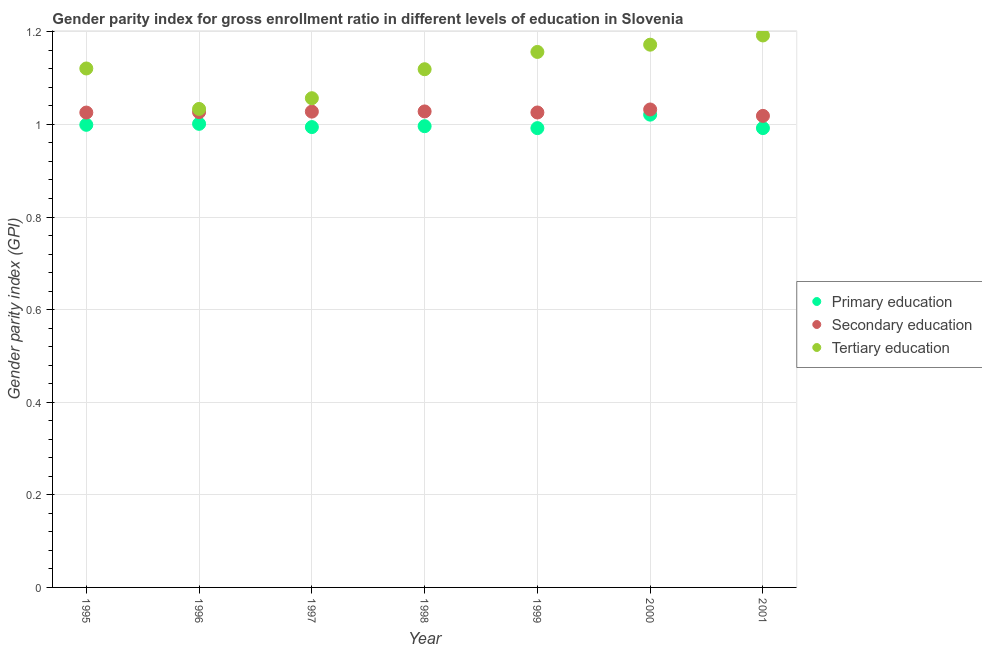What is the gender parity index in secondary education in 1996?
Provide a succinct answer. 1.03. Across all years, what is the maximum gender parity index in secondary education?
Your response must be concise. 1.03. Across all years, what is the minimum gender parity index in primary education?
Your answer should be very brief. 0.99. In which year was the gender parity index in secondary education maximum?
Provide a short and direct response. 2000. In which year was the gender parity index in tertiary education minimum?
Your answer should be compact. 1996. What is the total gender parity index in secondary education in the graph?
Offer a terse response. 7.18. What is the difference between the gender parity index in tertiary education in 1995 and that in 1998?
Your response must be concise. 0. What is the difference between the gender parity index in secondary education in 2001 and the gender parity index in primary education in 1999?
Ensure brevity in your answer.  0.03. What is the average gender parity index in secondary education per year?
Keep it short and to the point. 1.03. In the year 1997, what is the difference between the gender parity index in tertiary education and gender parity index in secondary education?
Give a very brief answer. 0.03. In how many years, is the gender parity index in primary education greater than 1.04?
Offer a very short reply. 0. What is the ratio of the gender parity index in secondary education in 1997 to that in 1998?
Keep it short and to the point. 1. Is the gender parity index in secondary education in 1995 less than that in 1998?
Your response must be concise. Yes. What is the difference between the highest and the second highest gender parity index in secondary education?
Offer a terse response. 0. What is the difference between the highest and the lowest gender parity index in primary education?
Offer a terse response. 0.03. Is the sum of the gender parity index in primary education in 1997 and 2001 greater than the maximum gender parity index in tertiary education across all years?
Keep it short and to the point. Yes. Does the gender parity index in secondary education monotonically increase over the years?
Provide a succinct answer. No. Is the gender parity index in tertiary education strictly less than the gender parity index in primary education over the years?
Offer a terse response. No. How many dotlines are there?
Offer a very short reply. 3. How many years are there in the graph?
Offer a terse response. 7. What is the difference between two consecutive major ticks on the Y-axis?
Give a very brief answer. 0.2. Does the graph contain any zero values?
Ensure brevity in your answer.  No. Does the graph contain grids?
Ensure brevity in your answer.  Yes. How many legend labels are there?
Offer a very short reply. 3. What is the title of the graph?
Provide a succinct answer. Gender parity index for gross enrollment ratio in different levels of education in Slovenia. Does "Poland" appear as one of the legend labels in the graph?
Provide a short and direct response. No. What is the label or title of the Y-axis?
Give a very brief answer. Gender parity index (GPI). What is the Gender parity index (GPI) in Primary education in 1995?
Offer a very short reply. 1. What is the Gender parity index (GPI) of Secondary education in 1995?
Offer a terse response. 1.03. What is the Gender parity index (GPI) in Tertiary education in 1995?
Give a very brief answer. 1.12. What is the Gender parity index (GPI) in Primary education in 1996?
Ensure brevity in your answer.  1. What is the Gender parity index (GPI) of Secondary education in 1996?
Offer a terse response. 1.03. What is the Gender parity index (GPI) in Tertiary education in 1996?
Give a very brief answer. 1.03. What is the Gender parity index (GPI) in Primary education in 1997?
Keep it short and to the point. 0.99. What is the Gender parity index (GPI) of Secondary education in 1997?
Your response must be concise. 1.03. What is the Gender parity index (GPI) of Tertiary education in 1997?
Your answer should be compact. 1.06. What is the Gender parity index (GPI) of Primary education in 1998?
Make the answer very short. 1. What is the Gender parity index (GPI) in Secondary education in 1998?
Your response must be concise. 1.03. What is the Gender parity index (GPI) in Tertiary education in 1998?
Your response must be concise. 1.12. What is the Gender parity index (GPI) of Primary education in 1999?
Provide a succinct answer. 0.99. What is the Gender parity index (GPI) in Secondary education in 1999?
Provide a succinct answer. 1.03. What is the Gender parity index (GPI) in Tertiary education in 1999?
Offer a very short reply. 1.16. What is the Gender parity index (GPI) in Primary education in 2000?
Ensure brevity in your answer.  1.02. What is the Gender parity index (GPI) of Secondary education in 2000?
Give a very brief answer. 1.03. What is the Gender parity index (GPI) of Tertiary education in 2000?
Your answer should be very brief. 1.17. What is the Gender parity index (GPI) in Primary education in 2001?
Make the answer very short. 0.99. What is the Gender parity index (GPI) in Secondary education in 2001?
Offer a very short reply. 1.02. What is the Gender parity index (GPI) of Tertiary education in 2001?
Offer a very short reply. 1.19. Across all years, what is the maximum Gender parity index (GPI) of Primary education?
Your response must be concise. 1.02. Across all years, what is the maximum Gender parity index (GPI) in Secondary education?
Provide a succinct answer. 1.03. Across all years, what is the maximum Gender parity index (GPI) in Tertiary education?
Your answer should be very brief. 1.19. Across all years, what is the minimum Gender parity index (GPI) of Primary education?
Offer a very short reply. 0.99. Across all years, what is the minimum Gender parity index (GPI) of Secondary education?
Keep it short and to the point. 1.02. Across all years, what is the minimum Gender parity index (GPI) in Tertiary education?
Provide a succinct answer. 1.03. What is the total Gender parity index (GPI) in Primary education in the graph?
Give a very brief answer. 7. What is the total Gender parity index (GPI) of Secondary education in the graph?
Your answer should be very brief. 7.18. What is the total Gender parity index (GPI) in Tertiary education in the graph?
Your answer should be compact. 7.85. What is the difference between the Gender parity index (GPI) in Primary education in 1995 and that in 1996?
Offer a very short reply. -0. What is the difference between the Gender parity index (GPI) in Secondary education in 1995 and that in 1996?
Provide a succinct answer. -0. What is the difference between the Gender parity index (GPI) in Tertiary education in 1995 and that in 1996?
Keep it short and to the point. 0.09. What is the difference between the Gender parity index (GPI) in Primary education in 1995 and that in 1997?
Your answer should be very brief. 0. What is the difference between the Gender parity index (GPI) in Secondary education in 1995 and that in 1997?
Offer a very short reply. -0. What is the difference between the Gender parity index (GPI) of Tertiary education in 1995 and that in 1997?
Your response must be concise. 0.06. What is the difference between the Gender parity index (GPI) of Primary education in 1995 and that in 1998?
Your response must be concise. 0. What is the difference between the Gender parity index (GPI) of Secondary education in 1995 and that in 1998?
Provide a succinct answer. -0. What is the difference between the Gender parity index (GPI) of Tertiary education in 1995 and that in 1998?
Make the answer very short. 0. What is the difference between the Gender parity index (GPI) in Primary education in 1995 and that in 1999?
Your answer should be compact. 0.01. What is the difference between the Gender parity index (GPI) of Secondary education in 1995 and that in 1999?
Give a very brief answer. -0. What is the difference between the Gender parity index (GPI) of Tertiary education in 1995 and that in 1999?
Your answer should be very brief. -0.04. What is the difference between the Gender parity index (GPI) of Primary education in 1995 and that in 2000?
Your answer should be very brief. -0.02. What is the difference between the Gender parity index (GPI) of Secondary education in 1995 and that in 2000?
Give a very brief answer. -0.01. What is the difference between the Gender parity index (GPI) of Tertiary education in 1995 and that in 2000?
Your response must be concise. -0.05. What is the difference between the Gender parity index (GPI) of Primary education in 1995 and that in 2001?
Provide a short and direct response. 0.01. What is the difference between the Gender parity index (GPI) in Secondary education in 1995 and that in 2001?
Keep it short and to the point. 0.01. What is the difference between the Gender parity index (GPI) in Tertiary education in 1995 and that in 2001?
Provide a succinct answer. -0.07. What is the difference between the Gender parity index (GPI) of Primary education in 1996 and that in 1997?
Provide a short and direct response. 0.01. What is the difference between the Gender parity index (GPI) of Secondary education in 1996 and that in 1997?
Keep it short and to the point. -0. What is the difference between the Gender parity index (GPI) of Tertiary education in 1996 and that in 1997?
Provide a short and direct response. -0.02. What is the difference between the Gender parity index (GPI) in Primary education in 1996 and that in 1998?
Provide a short and direct response. 0.01. What is the difference between the Gender parity index (GPI) in Secondary education in 1996 and that in 1998?
Provide a short and direct response. -0. What is the difference between the Gender parity index (GPI) in Tertiary education in 1996 and that in 1998?
Offer a terse response. -0.09. What is the difference between the Gender parity index (GPI) in Primary education in 1996 and that in 1999?
Your answer should be very brief. 0.01. What is the difference between the Gender parity index (GPI) of Secondary education in 1996 and that in 1999?
Offer a terse response. 0. What is the difference between the Gender parity index (GPI) in Tertiary education in 1996 and that in 1999?
Your response must be concise. -0.12. What is the difference between the Gender parity index (GPI) in Primary education in 1996 and that in 2000?
Provide a short and direct response. -0.02. What is the difference between the Gender parity index (GPI) in Secondary education in 1996 and that in 2000?
Give a very brief answer. -0.01. What is the difference between the Gender parity index (GPI) in Tertiary education in 1996 and that in 2000?
Ensure brevity in your answer.  -0.14. What is the difference between the Gender parity index (GPI) of Primary education in 1996 and that in 2001?
Your answer should be compact. 0.01. What is the difference between the Gender parity index (GPI) of Secondary education in 1996 and that in 2001?
Keep it short and to the point. 0.01. What is the difference between the Gender parity index (GPI) in Tertiary education in 1996 and that in 2001?
Offer a very short reply. -0.16. What is the difference between the Gender parity index (GPI) of Primary education in 1997 and that in 1998?
Ensure brevity in your answer.  -0. What is the difference between the Gender parity index (GPI) in Secondary education in 1997 and that in 1998?
Offer a terse response. -0. What is the difference between the Gender parity index (GPI) of Tertiary education in 1997 and that in 1998?
Your answer should be very brief. -0.06. What is the difference between the Gender parity index (GPI) in Primary education in 1997 and that in 1999?
Ensure brevity in your answer.  0. What is the difference between the Gender parity index (GPI) of Secondary education in 1997 and that in 1999?
Provide a short and direct response. 0. What is the difference between the Gender parity index (GPI) of Tertiary education in 1997 and that in 1999?
Your answer should be compact. -0.1. What is the difference between the Gender parity index (GPI) in Primary education in 1997 and that in 2000?
Give a very brief answer. -0.03. What is the difference between the Gender parity index (GPI) in Secondary education in 1997 and that in 2000?
Provide a short and direct response. -0. What is the difference between the Gender parity index (GPI) of Tertiary education in 1997 and that in 2000?
Your response must be concise. -0.12. What is the difference between the Gender parity index (GPI) in Primary education in 1997 and that in 2001?
Provide a succinct answer. 0. What is the difference between the Gender parity index (GPI) of Secondary education in 1997 and that in 2001?
Keep it short and to the point. 0.01. What is the difference between the Gender parity index (GPI) of Tertiary education in 1997 and that in 2001?
Your answer should be compact. -0.14. What is the difference between the Gender parity index (GPI) in Primary education in 1998 and that in 1999?
Ensure brevity in your answer.  0. What is the difference between the Gender parity index (GPI) of Secondary education in 1998 and that in 1999?
Your answer should be very brief. 0. What is the difference between the Gender parity index (GPI) of Tertiary education in 1998 and that in 1999?
Your response must be concise. -0.04. What is the difference between the Gender parity index (GPI) in Primary education in 1998 and that in 2000?
Offer a very short reply. -0.02. What is the difference between the Gender parity index (GPI) of Secondary education in 1998 and that in 2000?
Ensure brevity in your answer.  -0. What is the difference between the Gender parity index (GPI) in Tertiary education in 1998 and that in 2000?
Your answer should be very brief. -0.05. What is the difference between the Gender parity index (GPI) in Primary education in 1998 and that in 2001?
Your answer should be very brief. 0. What is the difference between the Gender parity index (GPI) in Secondary education in 1998 and that in 2001?
Offer a terse response. 0.01. What is the difference between the Gender parity index (GPI) in Tertiary education in 1998 and that in 2001?
Your answer should be very brief. -0.07. What is the difference between the Gender parity index (GPI) in Primary education in 1999 and that in 2000?
Your answer should be compact. -0.03. What is the difference between the Gender parity index (GPI) of Secondary education in 1999 and that in 2000?
Your answer should be very brief. -0.01. What is the difference between the Gender parity index (GPI) in Tertiary education in 1999 and that in 2000?
Provide a short and direct response. -0.02. What is the difference between the Gender parity index (GPI) of Primary education in 1999 and that in 2001?
Provide a succinct answer. -0. What is the difference between the Gender parity index (GPI) in Secondary education in 1999 and that in 2001?
Provide a succinct answer. 0.01. What is the difference between the Gender parity index (GPI) in Tertiary education in 1999 and that in 2001?
Your answer should be very brief. -0.04. What is the difference between the Gender parity index (GPI) of Primary education in 2000 and that in 2001?
Your response must be concise. 0.03. What is the difference between the Gender parity index (GPI) in Secondary education in 2000 and that in 2001?
Give a very brief answer. 0.01. What is the difference between the Gender parity index (GPI) of Tertiary education in 2000 and that in 2001?
Your answer should be very brief. -0.02. What is the difference between the Gender parity index (GPI) in Primary education in 1995 and the Gender parity index (GPI) in Secondary education in 1996?
Give a very brief answer. -0.03. What is the difference between the Gender parity index (GPI) of Primary education in 1995 and the Gender parity index (GPI) of Tertiary education in 1996?
Your answer should be very brief. -0.03. What is the difference between the Gender parity index (GPI) of Secondary education in 1995 and the Gender parity index (GPI) of Tertiary education in 1996?
Your response must be concise. -0.01. What is the difference between the Gender parity index (GPI) of Primary education in 1995 and the Gender parity index (GPI) of Secondary education in 1997?
Offer a terse response. -0.03. What is the difference between the Gender parity index (GPI) in Primary education in 1995 and the Gender parity index (GPI) in Tertiary education in 1997?
Give a very brief answer. -0.06. What is the difference between the Gender parity index (GPI) in Secondary education in 1995 and the Gender parity index (GPI) in Tertiary education in 1997?
Give a very brief answer. -0.03. What is the difference between the Gender parity index (GPI) of Primary education in 1995 and the Gender parity index (GPI) of Secondary education in 1998?
Provide a short and direct response. -0.03. What is the difference between the Gender parity index (GPI) in Primary education in 1995 and the Gender parity index (GPI) in Tertiary education in 1998?
Offer a terse response. -0.12. What is the difference between the Gender parity index (GPI) in Secondary education in 1995 and the Gender parity index (GPI) in Tertiary education in 1998?
Provide a succinct answer. -0.09. What is the difference between the Gender parity index (GPI) of Primary education in 1995 and the Gender parity index (GPI) of Secondary education in 1999?
Keep it short and to the point. -0.03. What is the difference between the Gender parity index (GPI) in Primary education in 1995 and the Gender parity index (GPI) in Tertiary education in 1999?
Provide a succinct answer. -0.16. What is the difference between the Gender parity index (GPI) in Secondary education in 1995 and the Gender parity index (GPI) in Tertiary education in 1999?
Provide a succinct answer. -0.13. What is the difference between the Gender parity index (GPI) in Primary education in 1995 and the Gender parity index (GPI) in Secondary education in 2000?
Offer a terse response. -0.03. What is the difference between the Gender parity index (GPI) of Primary education in 1995 and the Gender parity index (GPI) of Tertiary education in 2000?
Give a very brief answer. -0.17. What is the difference between the Gender parity index (GPI) in Secondary education in 1995 and the Gender parity index (GPI) in Tertiary education in 2000?
Offer a very short reply. -0.15. What is the difference between the Gender parity index (GPI) in Primary education in 1995 and the Gender parity index (GPI) in Secondary education in 2001?
Offer a very short reply. -0.02. What is the difference between the Gender parity index (GPI) of Primary education in 1995 and the Gender parity index (GPI) of Tertiary education in 2001?
Offer a terse response. -0.19. What is the difference between the Gender parity index (GPI) in Secondary education in 1995 and the Gender parity index (GPI) in Tertiary education in 2001?
Your response must be concise. -0.17. What is the difference between the Gender parity index (GPI) in Primary education in 1996 and the Gender parity index (GPI) in Secondary education in 1997?
Your answer should be compact. -0.03. What is the difference between the Gender parity index (GPI) in Primary education in 1996 and the Gender parity index (GPI) in Tertiary education in 1997?
Keep it short and to the point. -0.06. What is the difference between the Gender parity index (GPI) in Secondary education in 1996 and the Gender parity index (GPI) in Tertiary education in 1997?
Your answer should be very brief. -0.03. What is the difference between the Gender parity index (GPI) in Primary education in 1996 and the Gender parity index (GPI) in Secondary education in 1998?
Keep it short and to the point. -0.03. What is the difference between the Gender parity index (GPI) of Primary education in 1996 and the Gender parity index (GPI) of Tertiary education in 1998?
Keep it short and to the point. -0.12. What is the difference between the Gender parity index (GPI) of Secondary education in 1996 and the Gender parity index (GPI) of Tertiary education in 1998?
Offer a terse response. -0.09. What is the difference between the Gender parity index (GPI) in Primary education in 1996 and the Gender parity index (GPI) in Secondary education in 1999?
Your answer should be very brief. -0.02. What is the difference between the Gender parity index (GPI) of Primary education in 1996 and the Gender parity index (GPI) of Tertiary education in 1999?
Your response must be concise. -0.16. What is the difference between the Gender parity index (GPI) in Secondary education in 1996 and the Gender parity index (GPI) in Tertiary education in 1999?
Keep it short and to the point. -0.13. What is the difference between the Gender parity index (GPI) of Primary education in 1996 and the Gender parity index (GPI) of Secondary education in 2000?
Your response must be concise. -0.03. What is the difference between the Gender parity index (GPI) of Primary education in 1996 and the Gender parity index (GPI) of Tertiary education in 2000?
Your answer should be very brief. -0.17. What is the difference between the Gender parity index (GPI) of Secondary education in 1996 and the Gender parity index (GPI) of Tertiary education in 2000?
Give a very brief answer. -0.15. What is the difference between the Gender parity index (GPI) of Primary education in 1996 and the Gender parity index (GPI) of Secondary education in 2001?
Make the answer very short. -0.02. What is the difference between the Gender parity index (GPI) of Primary education in 1996 and the Gender parity index (GPI) of Tertiary education in 2001?
Your answer should be very brief. -0.19. What is the difference between the Gender parity index (GPI) of Secondary education in 1996 and the Gender parity index (GPI) of Tertiary education in 2001?
Keep it short and to the point. -0.17. What is the difference between the Gender parity index (GPI) of Primary education in 1997 and the Gender parity index (GPI) of Secondary education in 1998?
Your answer should be very brief. -0.03. What is the difference between the Gender parity index (GPI) in Primary education in 1997 and the Gender parity index (GPI) in Tertiary education in 1998?
Your answer should be compact. -0.12. What is the difference between the Gender parity index (GPI) in Secondary education in 1997 and the Gender parity index (GPI) in Tertiary education in 1998?
Your answer should be very brief. -0.09. What is the difference between the Gender parity index (GPI) in Primary education in 1997 and the Gender parity index (GPI) in Secondary education in 1999?
Your answer should be compact. -0.03. What is the difference between the Gender parity index (GPI) in Primary education in 1997 and the Gender parity index (GPI) in Tertiary education in 1999?
Offer a terse response. -0.16. What is the difference between the Gender parity index (GPI) of Secondary education in 1997 and the Gender parity index (GPI) of Tertiary education in 1999?
Ensure brevity in your answer.  -0.13. What is the difference between the Gender parity index (GPI) of Primary education in 1997 and the Gender parity index (GPI) of Secondary education in 2000?
Offer a very short reply. -0.04. What is the difference between the Gender parity index (GPI) in Primary education in 1997 and the Gender parity index (GPI) in Tertiary education in 2000?
Offer a terse response. -0.18. What is the difference between the Gender parity index (GPI) of Secondary education in 1997 and the Gender parity index (GPI) of Tertiary education in 2000?
Your answer should be compact. -0.14. What is the difference between the Gender parity index (GPI) in Primary education in 1997 and the Gender parity index (GPI) in Secondary education in 2001?
Your answer should be compact. -0.02. What is the difference between the Gender parity index (GPI) of Primary education in 1997 and the Gender parity index (GPI) of Tertiary education in 2001?
Keep it short and to the point. -0.2. What is the difference between the Gender parity index (GPI) in Secondary education in 1997 and the Gender parity index (GPI) in Tertiary education in 2001?
Offer a very short reply. -0.16. What is the difference between the Gender parity index (GPI) of Primary education in 1998 and the Gender parity index (GPI) of Secondary education in 1999?
Your response must be concise. -0.03. What is the difference between the Gender parity index (GPI) of Primary education in 1998 and the Gender parity index (GPI) of Tertiary education in 1999?
Keep it short and to the point. -0.16. What is the difference between the Gender parity index (GPI) in Secondary education in 1998 and the Gender parity index (GPI) in Tertiary education in 1999?
Ensure brevity in your answer.  -0.13. What is the difference between the Gender parity index (GPI) of Primary education in 1998 and the Gender parity index (GPI) of Secondary education in 2000?
Give a very brief answer. -0.04. What is the difference between the Gender parity index (GPI) in Primary education in 1998 and the Gender parity index (GPI) in Tertiary education in 2000?
Ensure brevity in your answer.  -0.18. What is the difference between the Gender parity index (GPI) of Secondary education in 1998 and the Gender parity index (GPI) of Tertiary education in 2000?
Your answer should be very brief. -0.14. What is the difference between the Gender parity index (GPI) of Primary education in 1998 and the Gender parity index (GPI) of Secondary education in 2001?
Your answer should be compact. -0.02. What is the difference between the Gender parity index (GPI) in Primary education in 1998 and the Gender parity index (GPI) in Tertiary education in 2001?
Give a very brief answer. -0.2. What is the difference between the Gender parity index (GPI) of Secondary education in 1998 and the Gender parity index (GPI) of Tertiary education in 2001?
Offer a very short reply. -0.16. What is the difference between the Gender parity index (GPI) of Primary education in 1999 and the Gender parity index (GPI) of Secondary education in 2000?
Offer a very short reply. -0.04. What is the difference between the Gender parity index (GPI) of Primary education in 1999 and the Gender parity index (GPI) of Tertiary education in 2000?
Offer a very short reply. -0.18. What is the difference between the Gender parity index (GPI) in Secondary education in 1999 and the Gender parity index (GPI) in Tertiary education in 2000?
Your answer should be compact. -0.15. What is the difference between the Gender parity index (GPI) of Primary education in 1999 and the Gender parity index (GPI) of Secondary education in 2001?
Offer a terse response. -0.03. What is the difference between the Gender parity index (GPI) of Primary education in 1999 and the Gender parity index (GPI) of Tertiary education in 2001?
Offer a terse response. -0.2. What is the difference between the Gender parity index (GPI) in Secondary education in 1999 and the Gender parity index (GPI) in Tertiary education in 2001?
Your answer should be compact. -0.17. What is the difference between the Gender parity index (GPI) in Primary education in 2000 and the Gender parity index (GPI) in Secondary education in 2001?
Your response must be concise. 0. What is the difference between the Gender parity index (GPI) of Primary education in 2000 and the Gender parity index (GPI) of Tertiary education in 2001?
Your answer should be very brief. -0.17. What is the difference between the Gender parity index (GPI) of Secondary education in 2000 and the Gender parity index (GPI) of Tertiary education in 2001?
Provide a succinct answer. -0.16. What is the average Gender parity index (GPI) in Primary education per year?
Make the answer very short. 1. What is the average Gender parity index (GPI) in Secondary education per year?
Your response must be concise. 1.03. What is the average Gender parity index (GPI) in Tertiary education per year?
Your answer should be very brief. 1.12. In the year 1995, what is the difference between the Gender parity index (GPI) in Primary education and Gender parity index (GPI) in Secondary education?
Offer a very short reply. -0.03. In the year 1995, what is the difference between the Gender parity index (GPI) of Primary education and Gender parity index (GPI) of Tertiary education?
Keep it short and to the point. -0.12. In the year 1995, what is the difference between the Gender parity index (GPI) in Secondary education and Gender parity index (GPI) in Tertiary education?
Ensure brevity in your answer.  -0.1. In the year 1996, what is the difference between the Gender parity index (GPI) of Primary education and Gender parity index (GPI) of Secondary education?
Offer a very short reply. -0.03. In the year 1996, what is the difference between the Gender parity index (GPI) in Primary education and Gender parity index (GPI) in Tertiary education?
Your response must be concise. -0.03. In the year 1996, what is the difference between the Gender parity index (GPI) in Secondary education and Gender parity index (GPI) in Tertiary education?
Ensure brevity in your answer.  -0.01. In the year 1997, what is the difference between the Gender parity index (GPI) of Primary education and Gender parity index (GPI) of Secondary education?
Offer a very short reply. -0.03. In the year 1997, what is the difference between the Gender parity index (GPI) in Primary education and Gender parity index (GPI) in Tertiary education?
Provide a succinct answer. -0.06. In the year 1997, what is the difference between the Gender parity index (GPI) of Secondary education and Gender parity index (GPI) of Tertiary education?
Provide a succinct answer. -0.03. In the year 1998, what is the difference between the Gender parity index (GPI) of Primary education and Gender parity index (GPI) of Secondary education?
Make the answer very short. -0.03. In the year 1998, what is the difference between the Gender parity index (GPI) in Primary education and Gender parity index (GPI) in Tertiary education?
Offer a very short reply. -0.12. In the year 1998, what is the difference between the Gender parity index (GPI) of Secondary education and Gender parity index (GPI) of Tertiary education?
Offer a terse response. -0.09. In the year 1999, what is the difference between the Gender parity index (GPI) in Primary education and Gender parity index (GPI) in Secondary education?
Make the answer very short. -0.03. In the year 1999, what is the difference between the Gender parity index (GPI) in Primary education and Gender parity index (GPI) in Tertiary education?
Make the answer very short. -0.16. In the year 1999, what is the difference between the Gender parity index (GPI) of Secondary education and Gender parity index (GPI) of Tertiary education?
Provide a succinct answer. -0.13. In the year 2000, what is the difference between the Gender parity index (GPI) in Primary education and Gender parity index (GPI) in Secondary education?
Keep it short and to the point. -0.01. In the year 2000, what is the difference between the Gender parity index (GPI) in Primary education and Gender parity index (GPI) in Tertiary education?
Make the answer very short. -0.15. In the year 2000, what is the difference between the Gender parity index (GPI) of Secondary education and Gender parity index (GPI) of Tertiary education?
Your response must be concise. -0.14. In the year 2001, what is the difference between the Gender parity index (GPI) in Primary education and Gender parity index (GPI) in Secondary education?
Ensure brevity in your answer.  -0.03. In the year 2001, what is the difference between the Gender parity index (GPI) of Primary education and Gender parity index (GPI) of Tertiary education?
Offer a terse response. -0.2. In the year 2001, what is the difference between the Gender parity index (GPI) of Secondary education and Gender parity index (GPI) of Tertiary education?
Offer a very short reply. -0.17. What is the ratio of the Gender parity index (GPI) in Primary education in 1995 to that in 1996?
Provide a succinct answer. 1. What is the ratio of the Gender parity index (GPI) in Secondary education in 1995 to that in 1996?
Ensure brevity in your answer.  1. What is the ratio of the Gender parity index (GPI) of Tertiary education in 1995 to that in 1996?
Ensure brevity in your answer.  1.08. What is the ratio of the Gender parity index (GPI) in Primary education in 1995 to that in 1997?
Your answer should be compact. 1. What is the ratio of the Gender parity index (GPI) of Secondary education in 1995 to that in 1997?
Provide a short and direct response. 1. What is the ratio of the Gender parity index (GPI) of Tertiary education in 1995 to that in 1997?
Offer a very short reply. 1.06. What is the ratio of the Gender parity index (GPI) in Primary education in 1995 to that in 1998?
Ensure brevity in your answer.  1. What is the ratio of the Gender parity index (GPI) of Tertiary education in 1995 to that in 1999?
Offer a very short reply. 0.97. What is the ratio of the Gender parity index (GPI) in Primary education in 1995 to that in 2000?
Provide a succinct answer. 0.98. What is the ratio of the Gender parity index (GPI) of Tertiary education in 1995 to that in 2000?
Offer a terse response. 0.96. What is the ratio of the Gender parity index (GPI) in Primary education in 1995 to that in 2001?
Offer a terse response. 1.01. What is the ratio of the Gender parity index (GPI) of Tertiary education in 1995 to that in 2001?
Offer a terse response. 0.94. What is the ratio of the Gender parity index (GPI) in Secondary education in 1996 to that in 1997?
Give a very brief answer. 1. What is the ratio of the Gender parity index (GPI) in Tertiary education in 1996 to that in 1997?
Ensure brevity in your answer.  0.98. What is the ratio of the Gender parity index (GPI) of Secondary education in 1996 to that in 1998?
Your response must be concise. 1. What is the ratio of the Gender parity index (GPI) of Tertiary education in 1996 to that in 1998?
Offer a very short reply. 0.92. What is the ratio of the Gender parity index (GPI) in Primary education in 1996 to that in 1999?
Keep it short and to the point. 1.01. What is the ratio of the Gender parity index (GPI) of Tertiary education in 1996 to that in 1999?
Offer a terse response. 0.89. What is the ratio of the Gender parity index (GPI) of Primary education in 1996 to that in 2000?
Offer a terse response. 0.98. What is the ratio of the Gender parity index (GPI) of Tertiary education in 1996 to that in 2000?
Offer a very short reply. 0.88. What is the ratio of the Gender parity index (GPI) in Primary education in 1996 to that in 2001?
Provide a short and direct response. 1.01. What is the ratio of the Gender parity index (GPI) of Secondary education in 1996 to that in 2001?
Provide a short and direct response. 1.01. What is the ratio of the Gender parity index (GPI) of Tertiary education in 1996 to that in 2001?
Offer a very short reply. 0.87. What is the ratio of the Gender parity index (GPI) of Tertiary education in 1997 to that in 1998?
Give a very brief answer. 0.94. What is the ratio of the Gender parity index (GPI) of Secondary education in 1997 to that in 1999?
Offer a very short reply. 1. What is the ratio of the Gender parity index (GPI) in Tertiary education in 1997 to that in 1999?
Your response must be concise. 0.91. What is the ratio of the Gender parity index (GPI) in Primary education in 1997 to that in 2000?
Offer a very short reply. 0.97. What is the ratio of the Gender parity index (GPI) of Secondary education in 1997 to that in 2000?
Your answer should be compact. 1. What is the ratio of the Gender parity index (GPI) of Tertiary education in 1997 to that in 2000?
Your answer should be compact. 0.9. What is the ratio of the Gender parity index (GPI) of Secondary education in 1997 to that in 2001?
Offer a terse response. 1.01. What is the ratio of the Gender parity index (GPI) of Tertiary education in 1997 to that in 2001?
Provide a short and direct response. 0.89. What is the ratio of the Gender parity index (GPI) in Primary education in 1998 to that in 1999?
Ensure brevity in your answer.  1. What is the ratio of the Gender parity index (GPI) of Secondary education in 1998 to that in 1999?
Your response must be concise. 1. What is the ratio of the Gender parity index (GPI) of Tertiary education in 1998 to that in 1999?
Your response must be concise. 0.97. What is the ratio of the Gender parity index (GPI) of Primary education in 1998 to that in 2000?
Keep it short and to the point. 0.98. What is the ratio of the Gender parity index (GPI) of Secondary education in 1998 to that in 2000?
Your response must be concise. 1. What is the ratio of the Gender parity index (GPI) of Tertiary education in 1998 to that in 2000?
Your response must be concise. 0.95. What is the ratio of the Gender parity index (GPI) in Secondary education in 1998 to that in 2001?
Make the answer very short. 1.01. What is the ratio of the Gender parity index (GPI) in Tertiary education in 1998 to that in 2001?
Make the answer very short. 0.94. What is the ratio of the Gender parity index (GPI) of Primary education in 1999 to that in 2000?
Keep it short and to the point. 0.97. What is the ratio of the Gender parity index (GPI) in Secondary education in 1999 to that in 2000?
Offer a very short reply. 0.99. What is the ratio of the Gender parity index (GPI) of Tertiary education in 1999 to that in 2000?
Keep it short and to the point. 0.99. What is the ratio of the Gender parity index (GPI) of Primary education in 1999 to that in 2001?
Keep it short and to the point. 1. What is the ratio of the Gender parity index (GPI) in Tertiary education in 1999 to that in 2001?
Your answer should be very brief. 0.97. What is the ratio of the Gender parity index (GPI) in Primary education in 2000 to that in 2001?
Ensure brevity in your answer.  1.03. What is the ratio of the Gender parity index (GPI) in Secondary education in 2000 to that in 2001?
Your response must be concise. 1.01. What is the ratio of the Gender parity index (GPI) in Tertiary education in 2000 to that in 2001?
Provide a short and direct response. 0.98. What is the difference between the highest and the second highest Gender parity index (GPI) in Primary education?
Keep it short and to the point. 0.02. What is the difference between the highest and the second highest Gender parity index (GPI) of Secondary education?
Offer a very short reply. 0. What is the difference between the highest and the second highest Gender parity index (GPI) in Tertiary education?
Provide a succinct answer. 0.02. What is the difference between the highest and the lowest Gender parity index (GPI) in Primary education?
Keep it short and to the point. 0.03. What is the difference between the highest and the lowest Gender parity index (GPI) in Secondary education?
Provide a succinct answer. 0.01. What is the difference between the highest and the lowest Gender parity index (GPI) of Tertiary education?
Your answer should be compact. 0.16. 